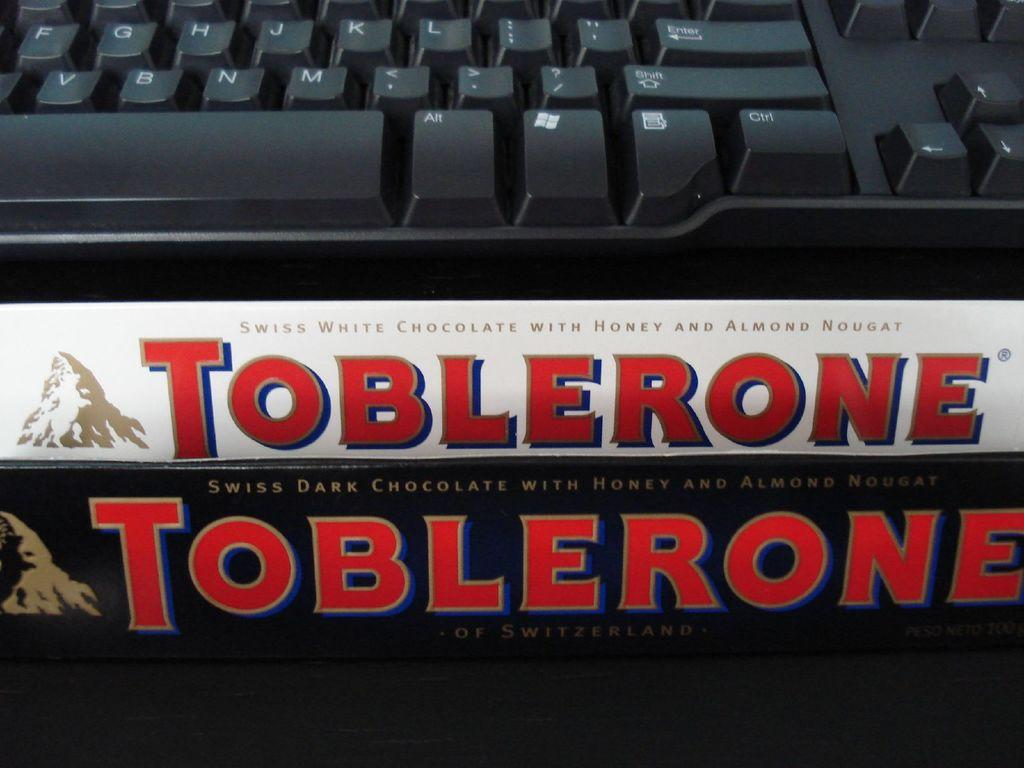<image>
Present a compact description of the photo's key features. Two packages of Toblerone are placed near a keyboard. 